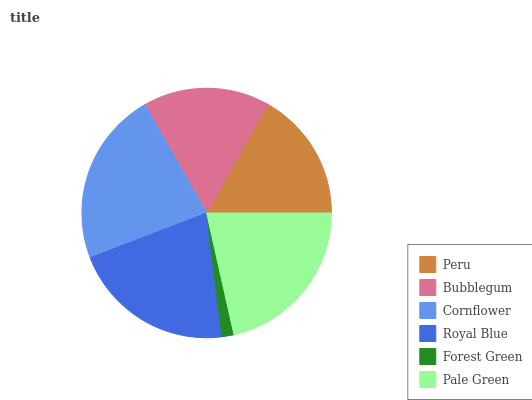Is Forest Green the minimum?
Answer yes or no. Yes. Is Cornflower the maximum?
Answer yes or no. Yes. Is Bubblegum the minimum?
Answer yes or no. No. Is Bubblegum the maximum?
Answer yes or no. No. Is Peru greater than Bubblegum?
Answer yes or no. Yes. Is Bubblegum less than Peru?
Answer yes or no. Yes. Is Bubblegum greater than Peru?
Answer yes or no. No. Is Peru less than Bubblegum?
Answer yes or no. No. Is Royal Blue the high median?
Answer yes or no. Yes. Is Peru the low median?
Answer yes or no. Yes. Is Pale Green the high median?
Answer yes or no. No. Is Cornflower the low median?
Answer yes or no. No. 